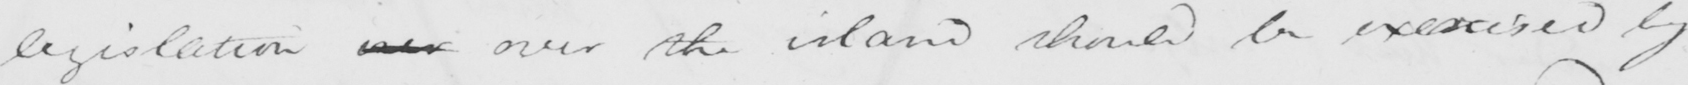Please transcribe the handwritten text in this image. legislation ever over the island should be exercised by 